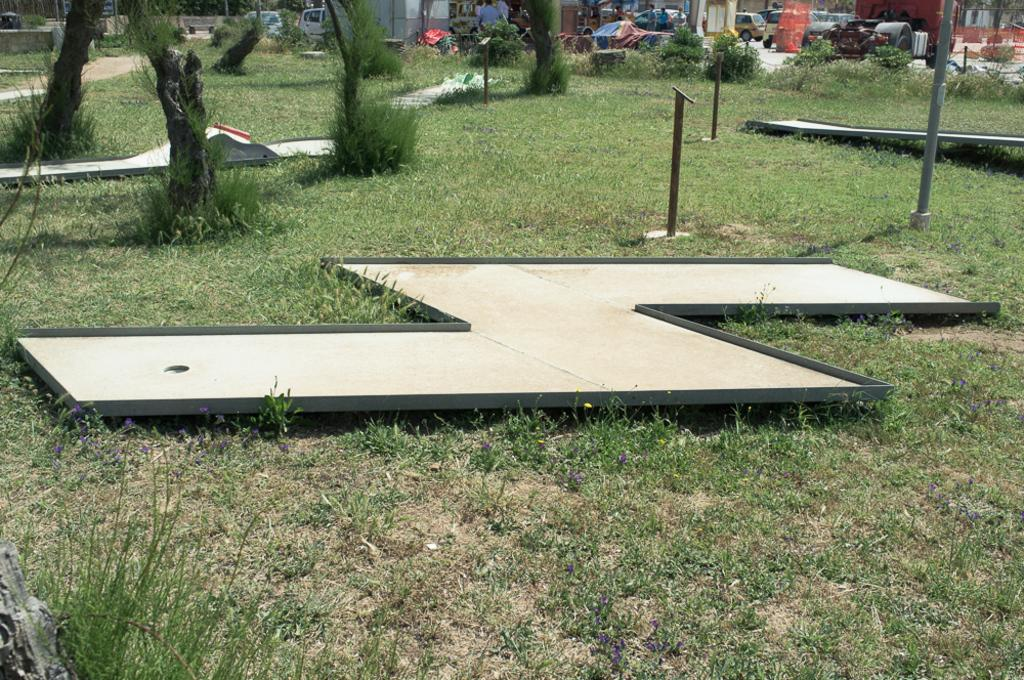What type of vegetation can be seen in the image? There are trees in the image. What object is located in the foreground? There is a board in the foreground. What types of man-made structures are visible in the image? There are vehicles, buildings, and a board in the image. Can you describe the people in the image? There is a group of people in the image. What is the ground surface like in the image? There is grass at the bottom of the image. Is there a government building visible on the island in the image? There is no island or government building mentioned in the image; it features trees, a board, vehicles, buildings, a group of people, and grass. Can you tell me how many cellars are present in the image? There is no mention of a cellar in the image; it features trees, a board, vehicles, buildings, a group of people, and grass. 